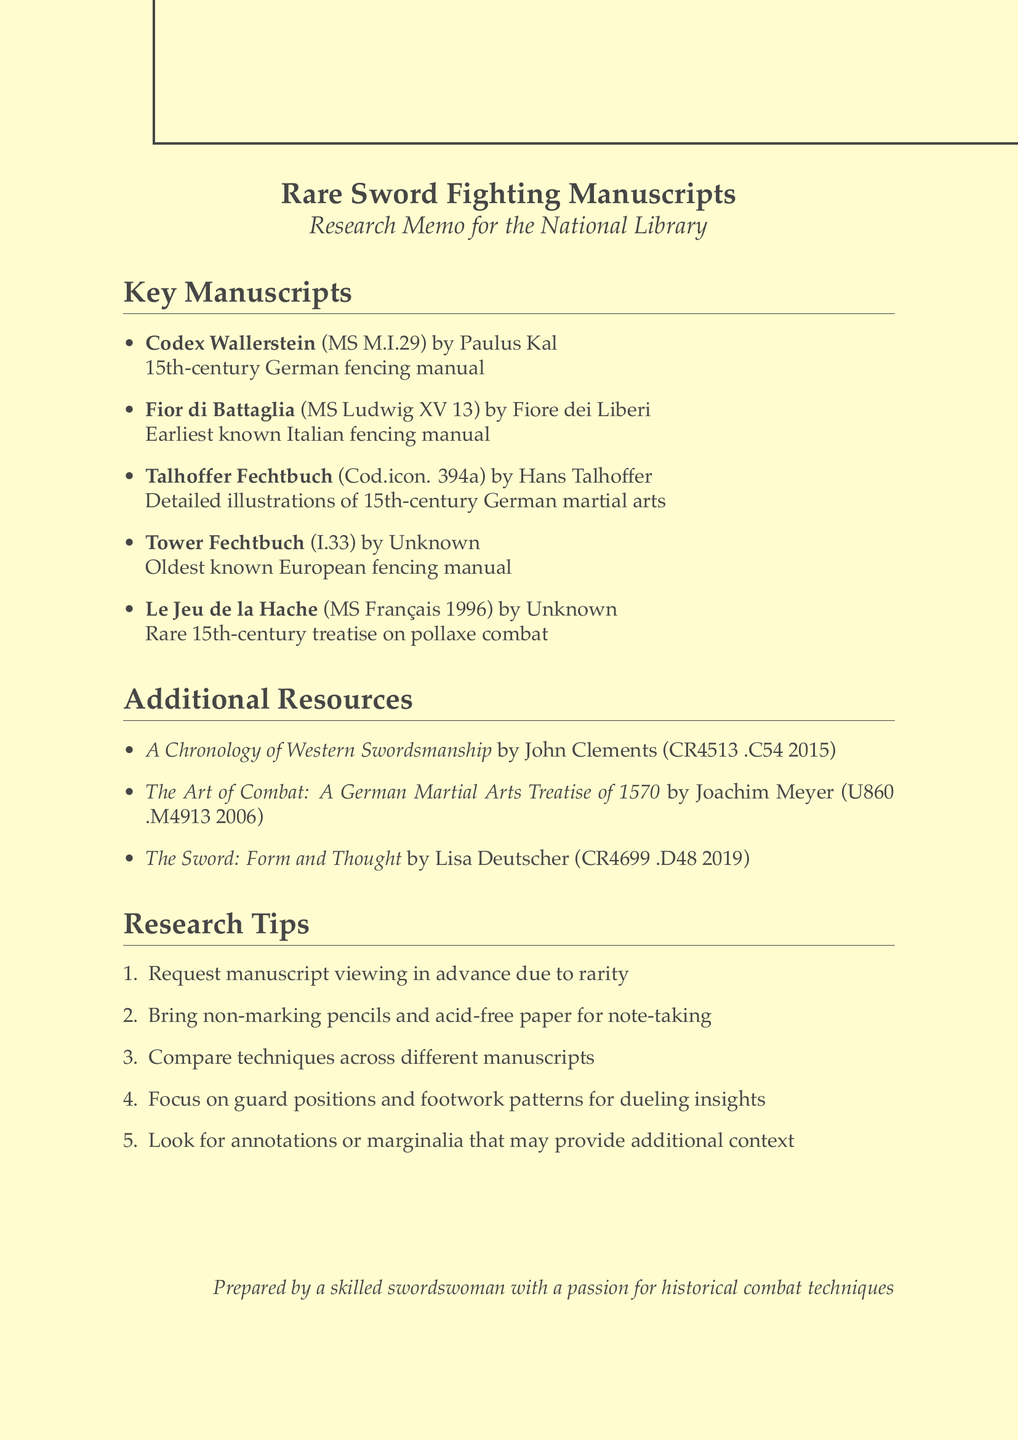What is the call number for Codex Wallerstein? The call number is specifically listed in the document under the manuscript's details.
Answer: MS M.I.29 Who is the author of Fior di Battaglia? The author is mentioned alongside the manuscript title in the document.
Answer: Fiore dei Liberi What chapter of interest is listed for Talhoffer Fechtbuch? The chapters of interest are provided as part of the manuscript details in the document.
Answer: Judicial combat How many key manuscripts are listed in the document? The document explicitly enumerates the manuscripts, providing a clear count.
Answer: Five What historical significance is attributed to the Tower Fechtbuch? The significance is explicitly stated in the manuscript's description within the document.
Answer: Oldest known European fencing manual What type of techniques are covered in Le Jeu de la Hache? The types of techniques are listed as part of the chapters of interest in the document.
Answer: Pollaxe techniques What is one of the research tips mentioned in the document? The research tips are provided as a numbered list in the document.
Answer: Request manuscript viewing in advance due to rarity Which manuscript has a call number of Cod.icon. 394a? Each manuscript's call number is clearly noted next to its title in the document.
Answer: Talhoffer Fechtbuch What is the title of the additional resource authored by John Clements? The titles of additional resources are listed explicitly in the document.
Answer: A Chronology of Western Swordsmanship 